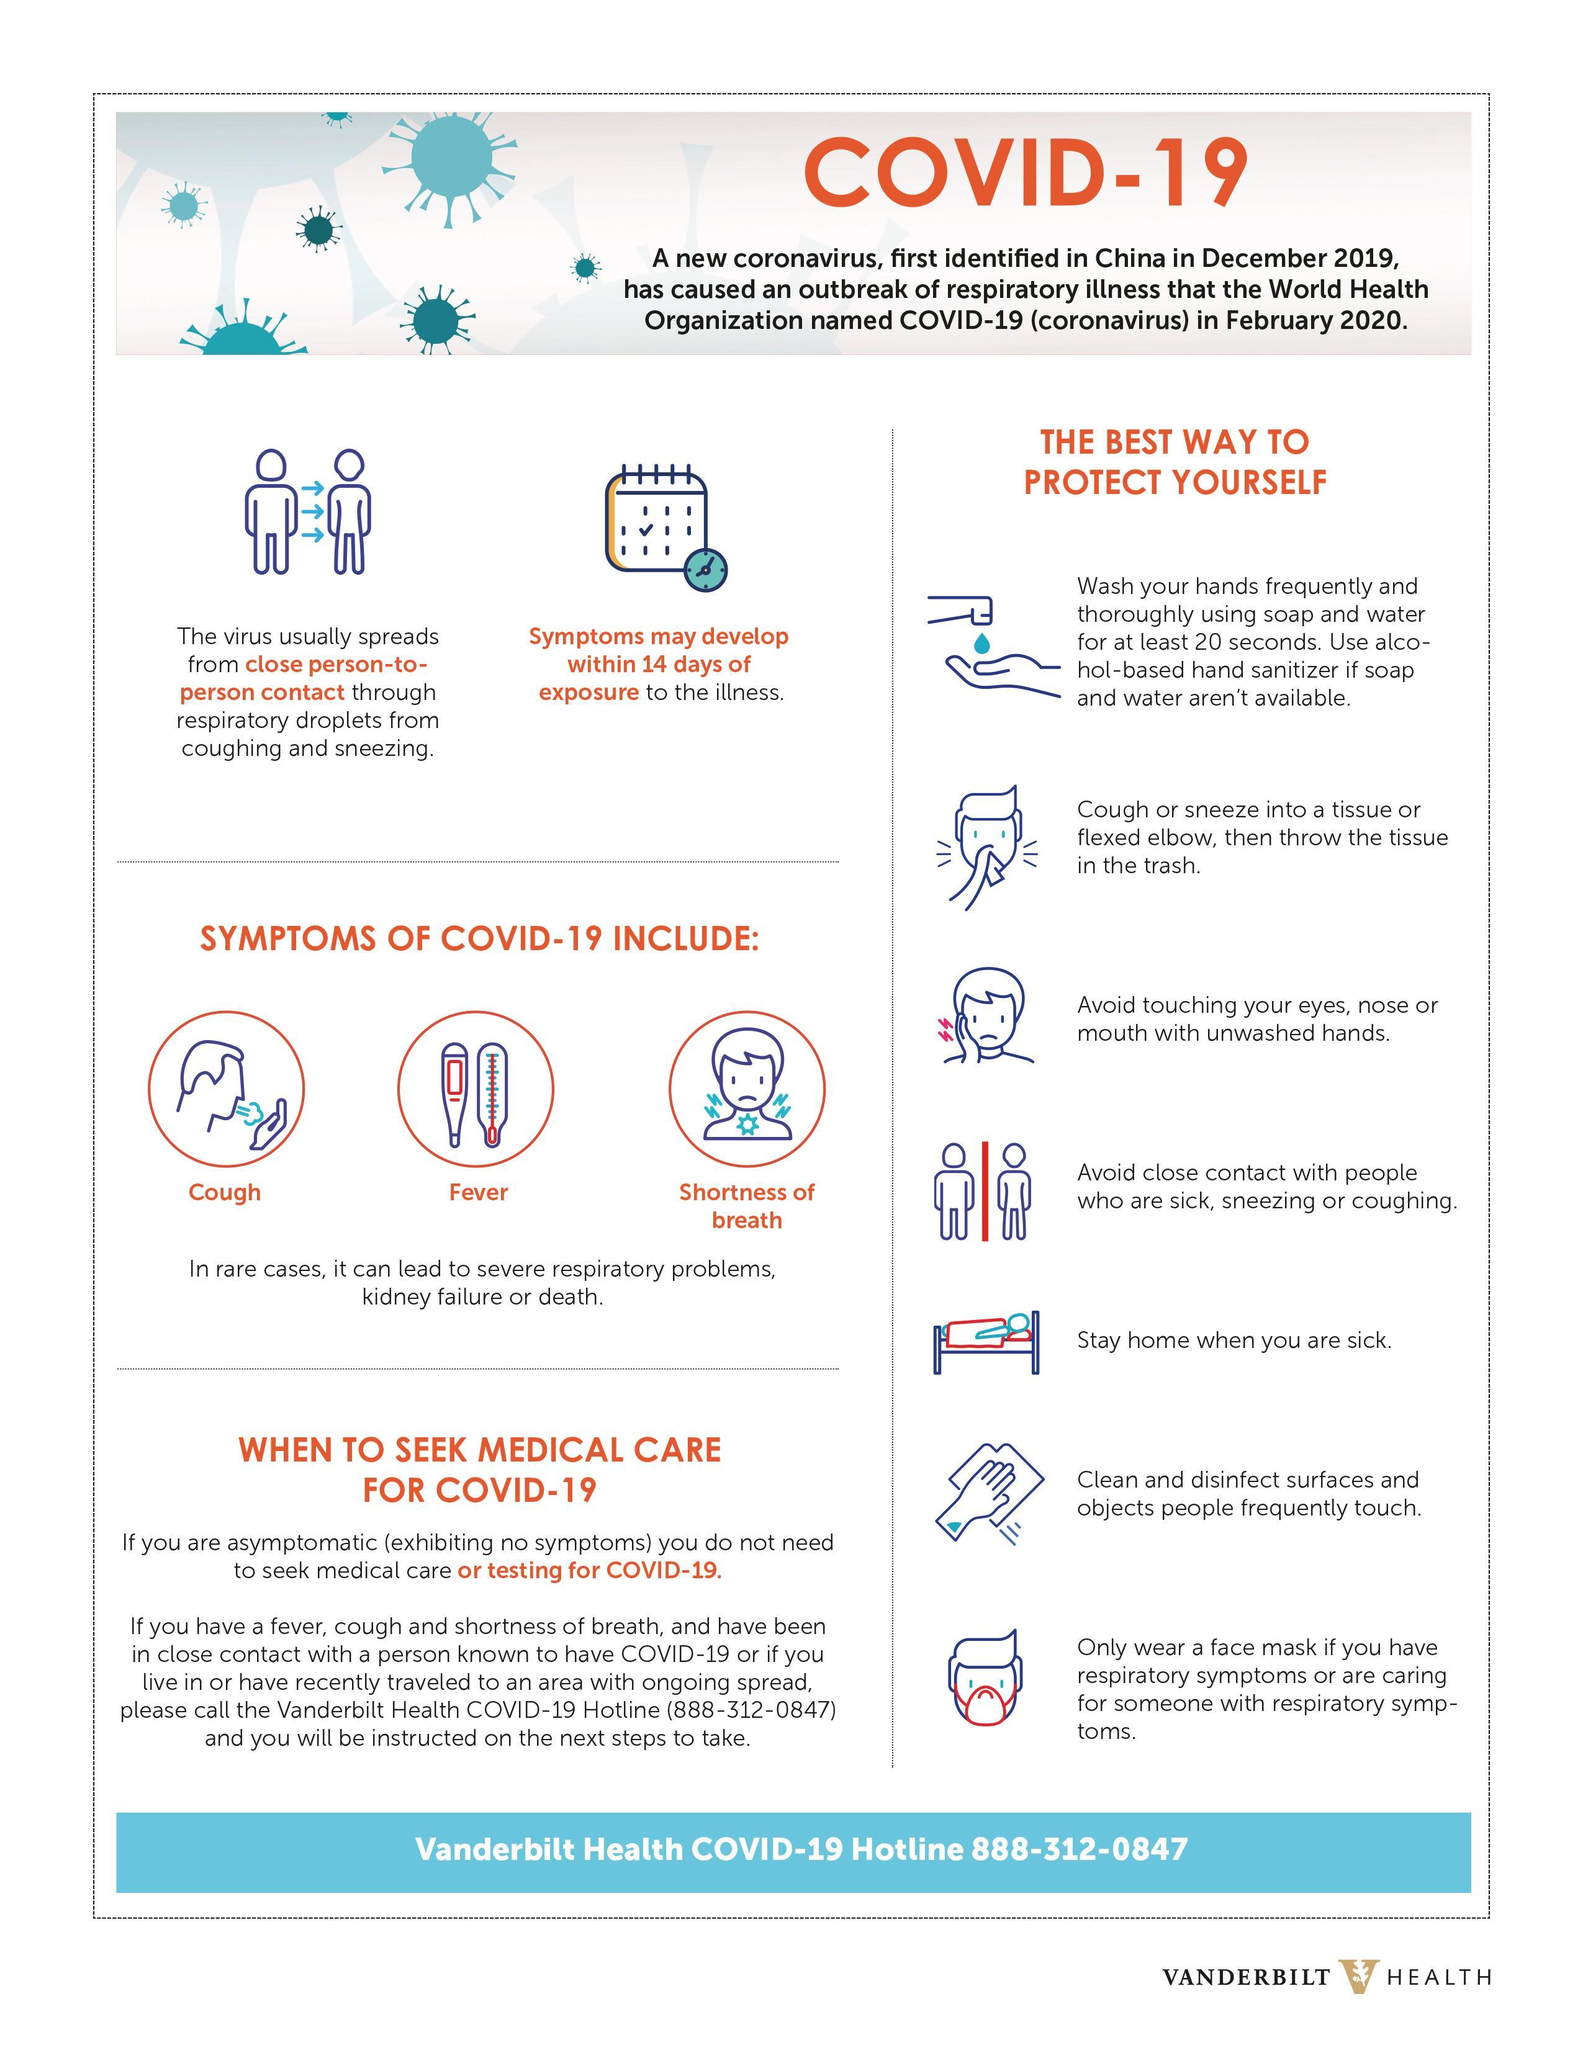How many points are under the heading "The best way to protect yourself"?
Answer the question with a short phrase. 7 Which all are the symptoms of covid other than fever? Cough, Shortness of breath 